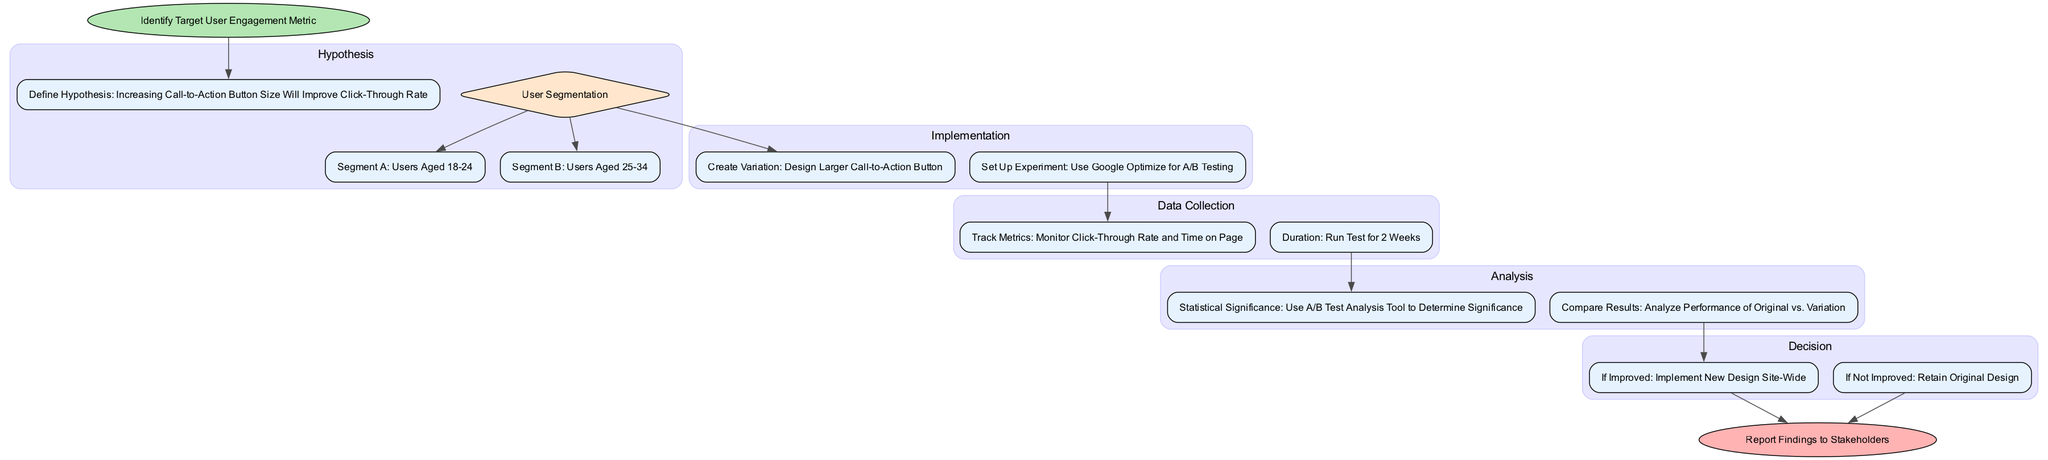What is the initial target metric for the A/B testing process? The process starts with identifying the target user engagement metric, which is stated at the beginning of the flow chart.
Answer: Identify Target User Engagement Metric What is the defined hypothesis for user engagement improvement? According to the diagram, the hypothesis is about increasing the call-to-action button size to improve the click-through rate, listed under the Hypothesis section.
Answer: Increasing Call-to-Action Button Size Will Improve Click-Through Rate Which segments are identified for the user segmentation? The segmentation identifies two groups: Users Aged 18-24 and Users Aged 25-34. These segments are shown as sub-nodes under the User Segmentation section.
Answer: Users Aged 18-24, Users Aged 25-34 How long is the duration for the A/B test? The diagram states that the test will run for 2 weeks as indicated in the Data Collection section.
Answer: Run Test for 2 Weeks What happens if the new design is improved? If the new design is found to improve engagement, the process indicates that the new design will be implemented site-wide, as per the Decision section.
Answer: Implement New Design Site-Wide What is the last step after reporting findings? Following the decision process, the final step listed in the diagram is to report findings to stakeholders. This is shown in the End node.
Answer: Report Findings to Stakeholders What type of tool is suggested for analyzing statistical significance? The diagram recommends using an A/B test analysis tool to determine statistical significance under the Analysis section.
Answer: Use A/B Test Analysis Tool How many main processes are there in the A/B testing flow? The diagram identifies five main process steps: Hypothesis, Implementation, Data Collection, Analysis, and Decision, which can be counted directly from the main steps listed.
Answer: 5 